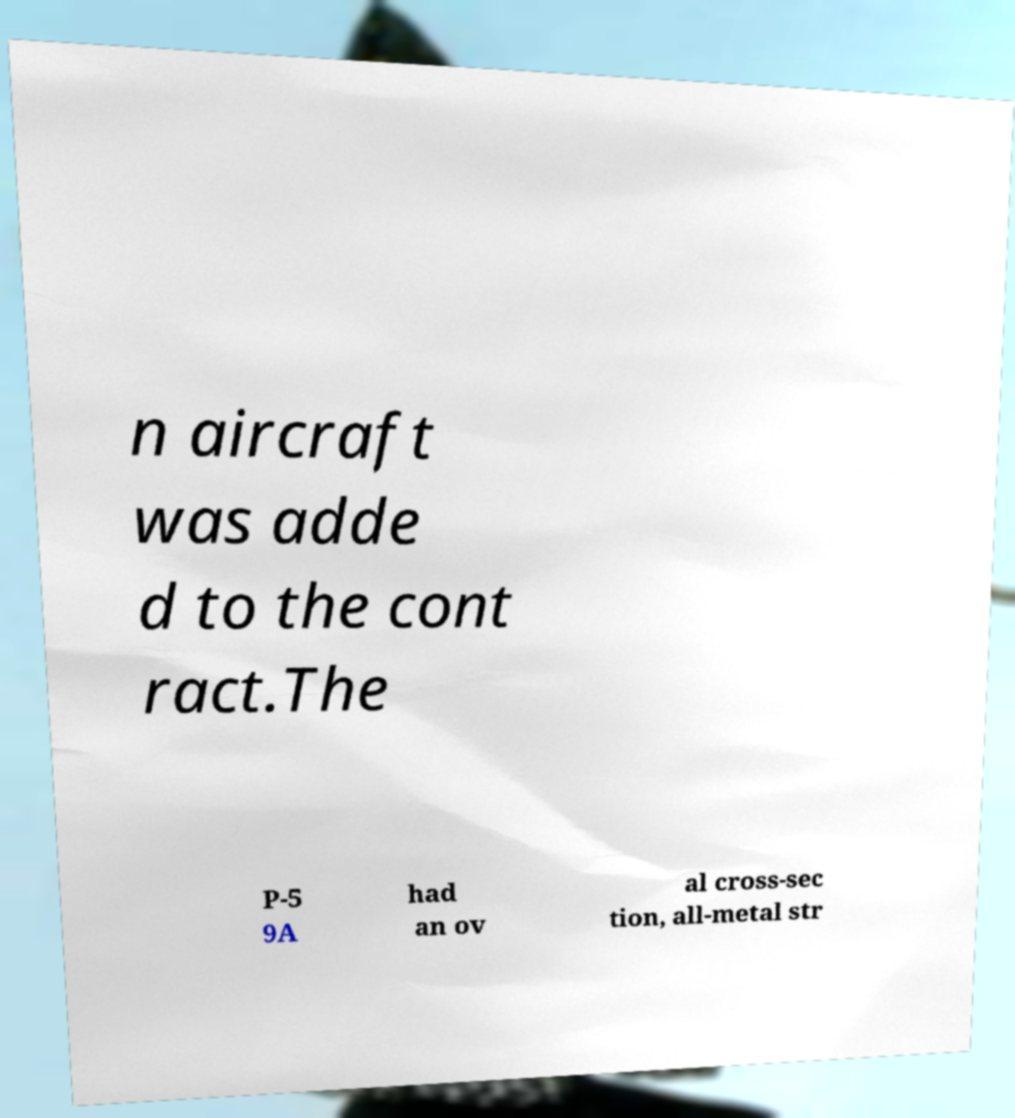Could you assist in decoding the text presented in this image and type it out clearly? n aircraft was adde d to the cont ract.The P-5 9A had an ov al cross-sec tion, all-metal str 